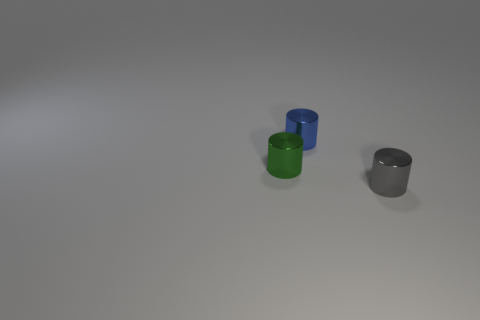Subtract all tiny blue metallic cylinders. How many cylinders are left? 2 Add 3 metal objects. How many objects exist? 6 Subtract all green cylinders. How many cylinders are left? 2 Subtract all tiny blue cylinders. Subtract all small gray things. How many objects are left? 1 Add 2 blue metallic objects. How many blue metallic objects are left? 3 Add 3 large purple rubber things. How many large purple rubber things exist? 3 Subtract 0 cyan spheres. How many objects are left? 3 Subtract 3 cylinders. How many cylinders are left? 0 Subtract all cyan cylinders. Subtract all blue cubes. How many cylinders are left? 3 